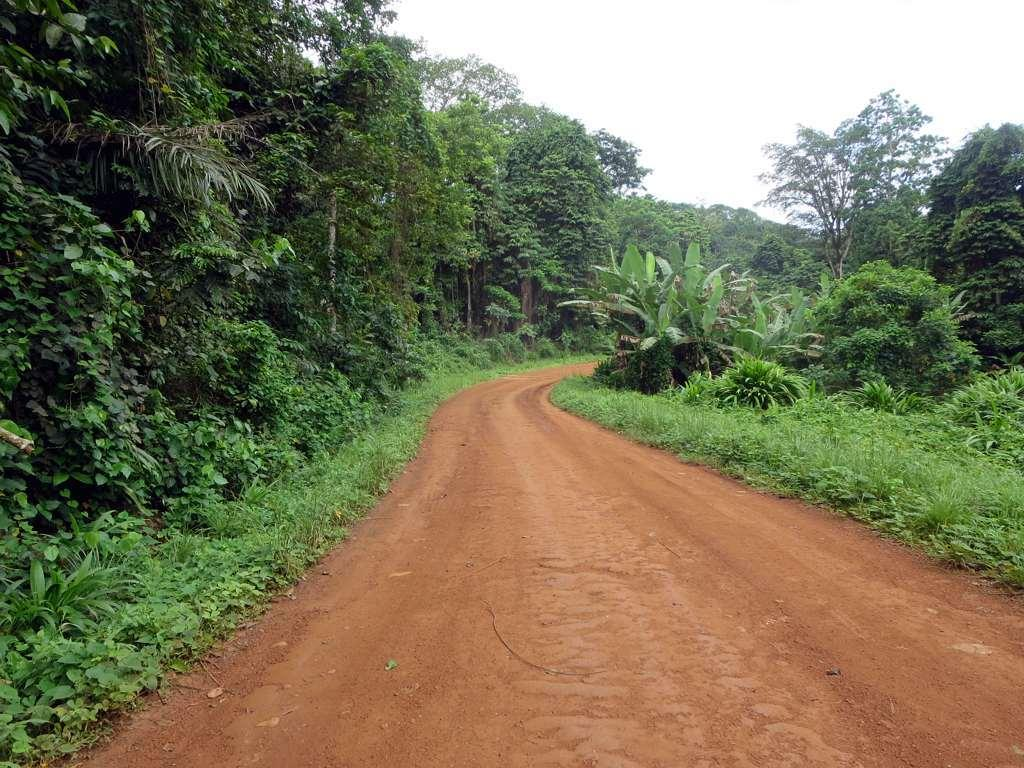What is located at the bottom of the image? There is a road in the bottom of the image. What type of vegetation can be seen in the background of the image? There are trees in the background of the image. What is visible at the top of the image? The sky is visible at the top of the image. Can you tell me how many cameras are visible in the image? There are no cameras present in the image. Is there a yak walking along the road in the image? There is no yak present in the image. 